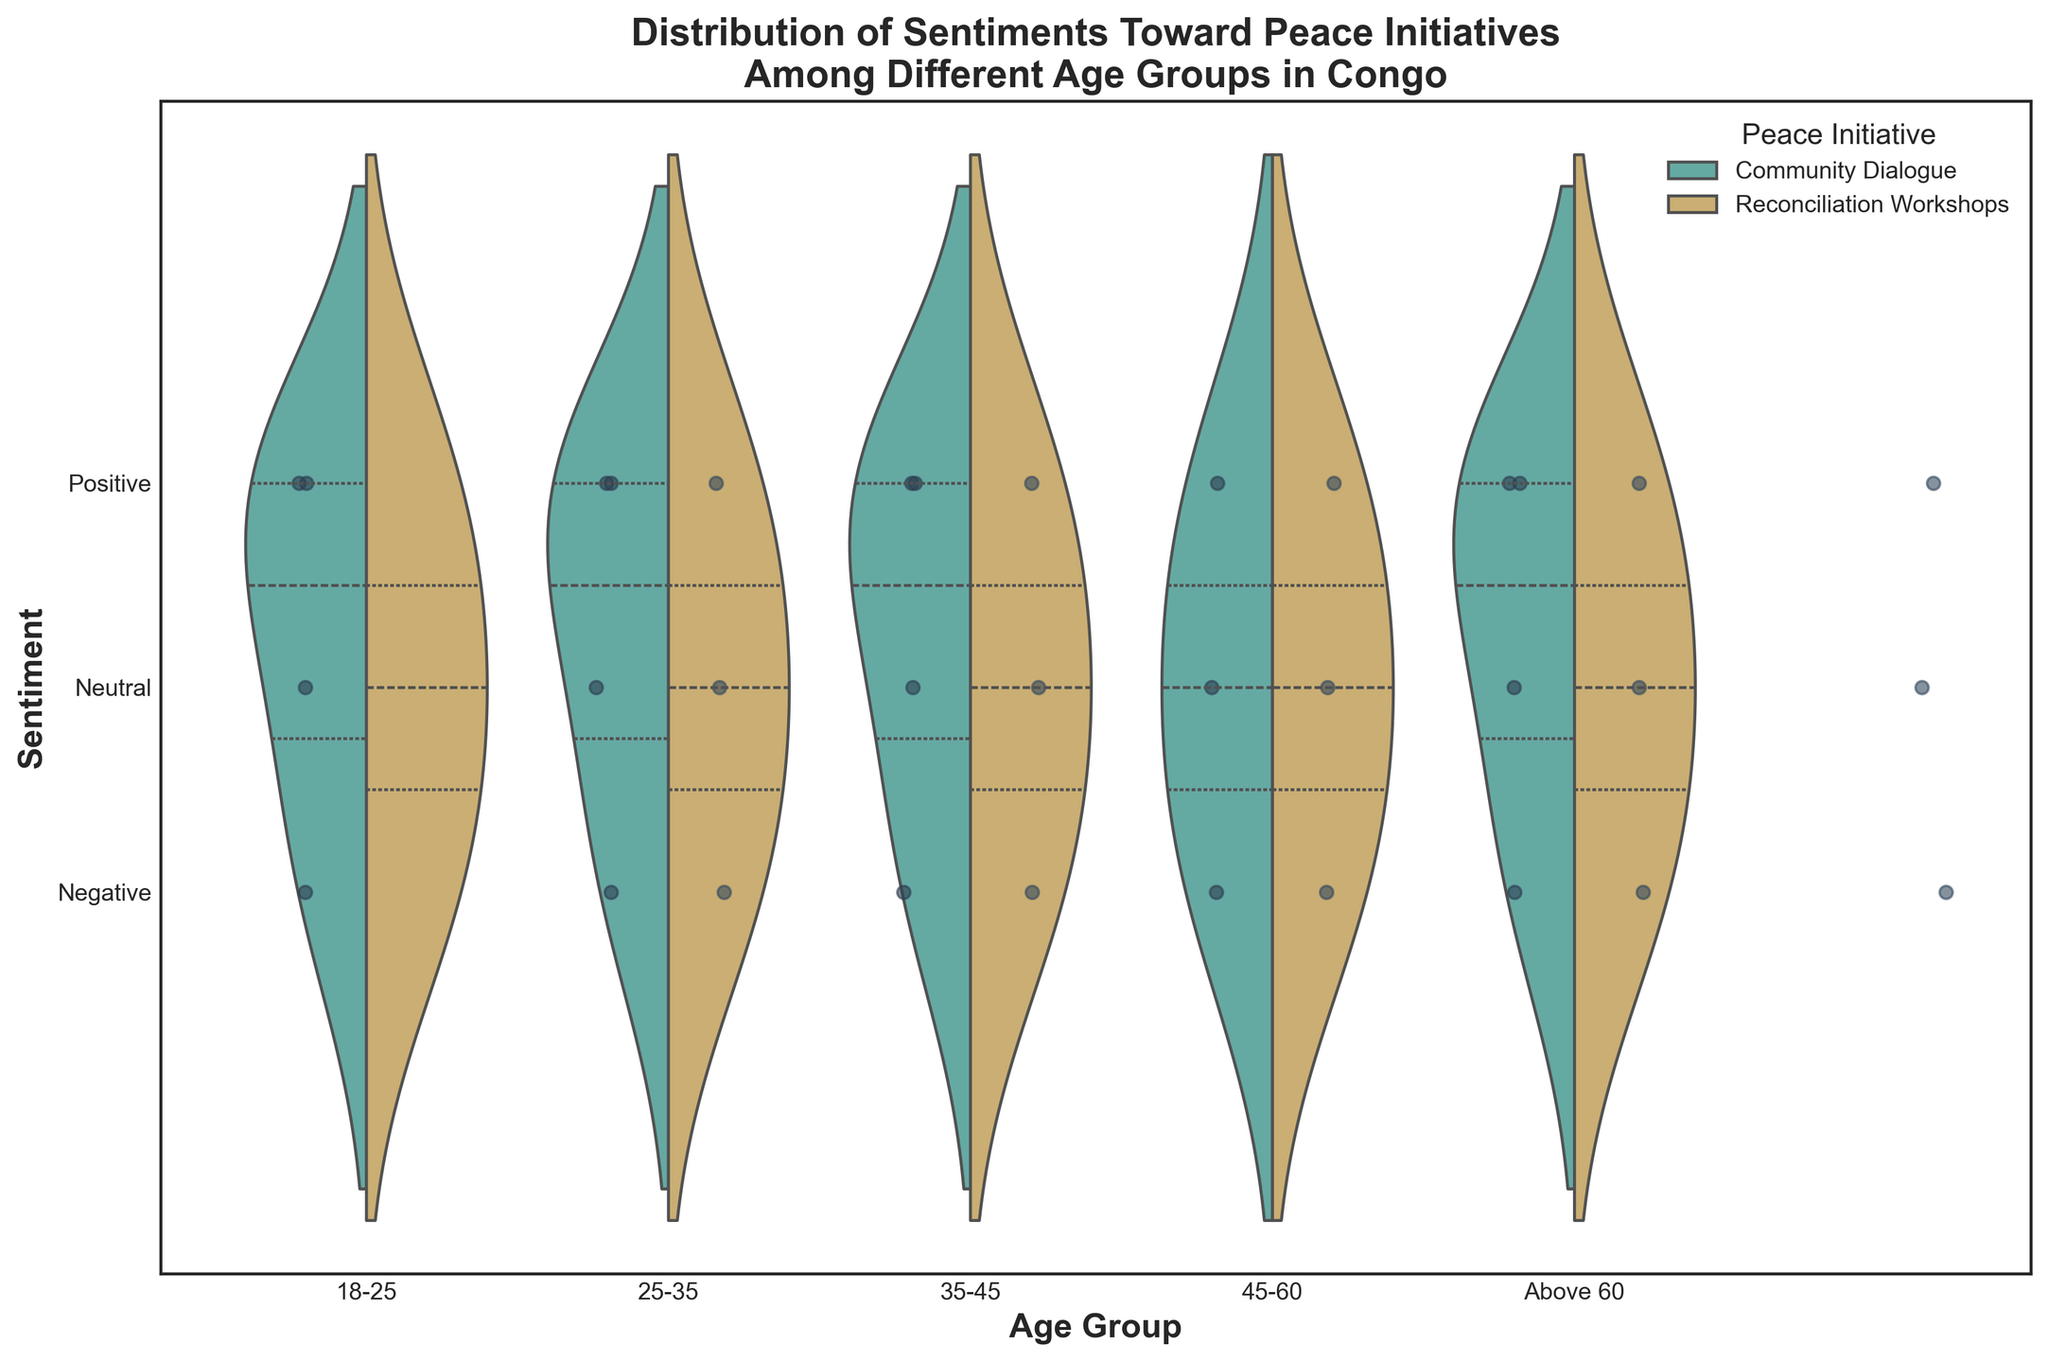What is the title of the figure? The title of the figure is usually located at the top and in this case reads 'Distribution of Sentiments Toward Peace Initiatives Among Different Age Groups in Congo'. This is directly visible when looking at the figure.
Answer: Distribution of Sentiments Toward Peace Initiatives Among Different Age Groups in Congo What does the color green represent in the figure? The figure's legend indicates that the color green is used for 'Community Dialogue'. This information is essential for interpreting the data distribution related to this particular peace initiative.
Answer: Community Dialogue Which age group shows the highest concentration of positive sentiments toward Reconciliation Workshops? By checking the distribution and concentration of the data points for each age group, the 25-35 age group indicates a high concentration of data points clustered at the 'Positive' sentiment level for Reconciliation Workshops.
Answer: 25-35 age group How does the sentiment for Community Dialogue compare between the 18-25 and 45-60 age groups? By visually comparing the distribution of the green shaded areas and the scatter points for Community Dialogue between the two specified age groups, you'll notice that the 18-25 age group has a more varied spread of sentiments, while the 45-60 age group has significant positive sentiment concentration with fewer negative points.
Answer: More varied in 18-25, more positive in 45-60 How do the median sentiments for Reconciliation Workshops differ between the 25-35 and 35-45 age groups? The median sentiment is indicated by the central line inside the violin shape. For Reconciliation Workshops, the median sentiment for the 25-35 age group is located higher (closer to 'Positive') compared to the 35-45 age group.
Answer: Higher in the 25-35 group Which peace initiative has a larger consistency (less spread) in sentiments across all age groups? Comparing the spread of sentiments for both colors across all age groups, Reconciliation Workshops (grayish color) show less spread in sentiments, indicating greater consistency compared to Community Dialogue which has a broader spread of sentiments.
Answer: Reconciliation Workshops What sentiment level do most Above 60 age group individuals have toward Community Dialogue? Observing the data points and the density of the violin plot for the Above 60 age group in green (Community Dialogue), most sentiments are concentrated around the 'Positive' level.
Answer: Positive In which age group does Community Dialogue have the widest spread of sentiments? By examining the width of the green violin plots across all age groups, the widest spread is observed in the 18-25 age group indicating varied sentiments from negative to positive.
Answer: 18-25 age group For the age group 35-45, which peace initiative shows a higher variability in sentiments? Assessing the width of the violin plots for the 35-45 age group, Community Dialogue (green) has a broader distribution compared to Reconciliation Workshops, indicating higher variability in sentiments.
Answer: Community Dialogue 